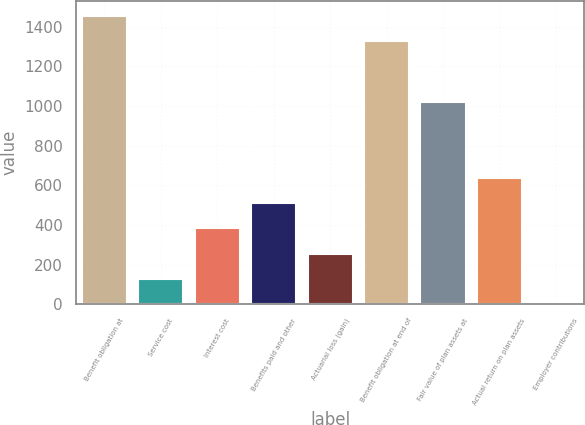Convert chart. <chart><loc_0><loc_0><loc_500><loc_500><bar_chart><fcel>Benefit obligation at<fcel>Service cost<fcel>Interest cost<fcel>Benefits paid and other<fcel>Actuarial loss (gain)<fcel>Benefit obligation at end of<fcel>Fair value of plan assets at<fcel>Actual return on plan assets<fcel>Employer contributions<nl><fcel>1455.74<fcel>128.22<fcel>383.46<fcel>511.08<fcel>255.84<fcel>1328.12<fcel>1021.56<fcel>638.7<fcel>0.6<nl></chart> 